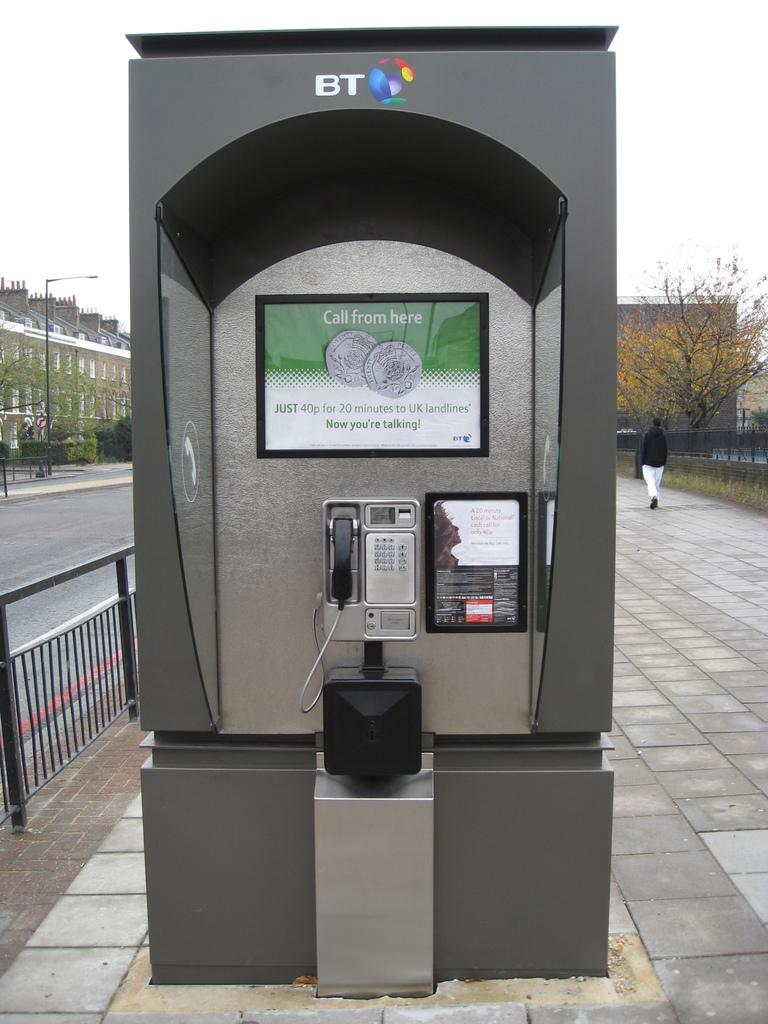Provide a one-sentence caption for the provided image. A BT telephone booth in the middle of the walk way. 